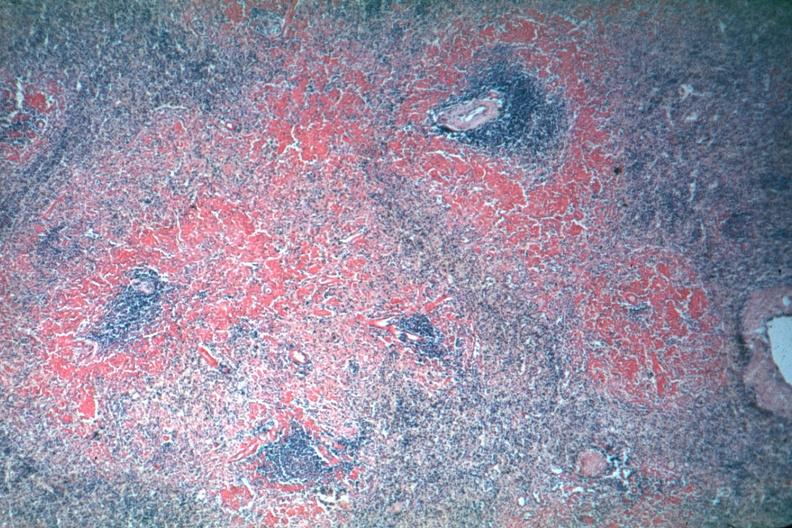s exposure not the best?
Answer the question using a single word or phrase. Yes 